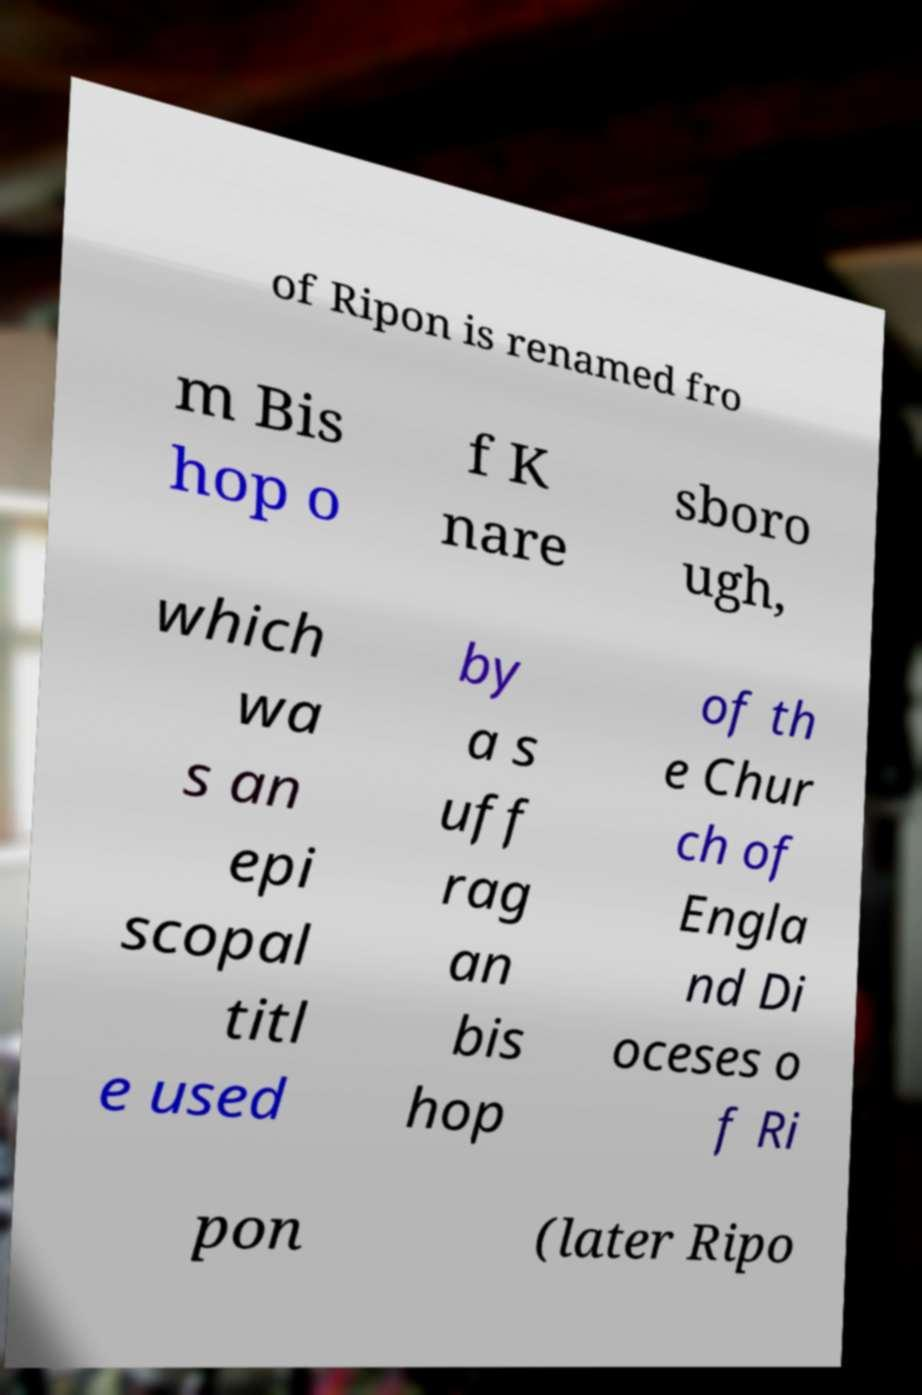For documentation purposes, I need the text within this image transcribed. Could you provide that? of Ripon is renamed fro m Bis hop o f K nare sboro ugh, which wa s an epi scopal titl e used by a s uff rag an bis hop of th e Chur ch of Engla nd Di oceses o f Ri pon (later Ripo 